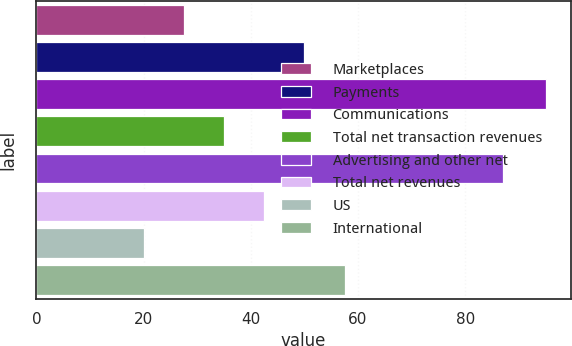<chart> <loc_0><loc_0><loc_500><loc_500><bar_chart><fcel>Marketplaces<fcel>Payments<fcel>Communications<fcel>Total net transaction revenues<fcel>Advertising and other net<fcel>Total net revenues<fcel>US<fcel>International<nl><fcel>27.5<fcel>50<fcel>95<fcel>35<fcel>87<fcel>42.5<fcel>20<fcel>57.5<nl></chart> 